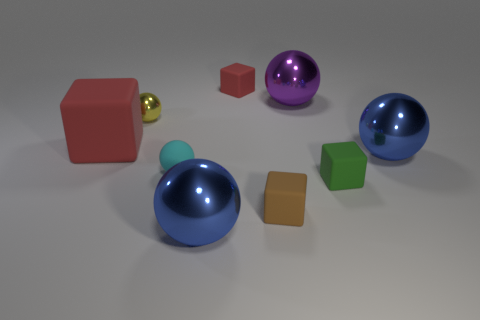What is the material of the other cube that is the same color as the big rubber cube?
Your response must be concise. Rubber. What number of shiny objects are either large blocks or large yellow things?
Provide a succinct answer. 0. The yellow metallic object has what size?
Offer a very short reply. Small. What number of objects are either small things or metal spheres that are on the right side of the green matte thing?
Give a very brief answer. 6. What number of other things are there of the same color as the big cube?
Offer a terse response. 1. There is a yellow object; is it the same size as the red object in front of the purple ball?
Keep it short and to the point. No. Is the size of the matte object behind the yellow metal thing the same as the tiny green object?
Ensure brevity in your answer.  Yes. How many other things are there of the same material as the tiny yellow object?
Keep it short and to the point. 3. Is the number of small yellow shiny balls that are on the right side of the tiny brown block the same as the number of blue metallic things to the left of the green rubber block?
Ensure brevity in your answer.  No. What color is the small rubber thing behind the large blue shiny ball right of the cube that is behind the large red matte object?
Your response must be concise. Red. 